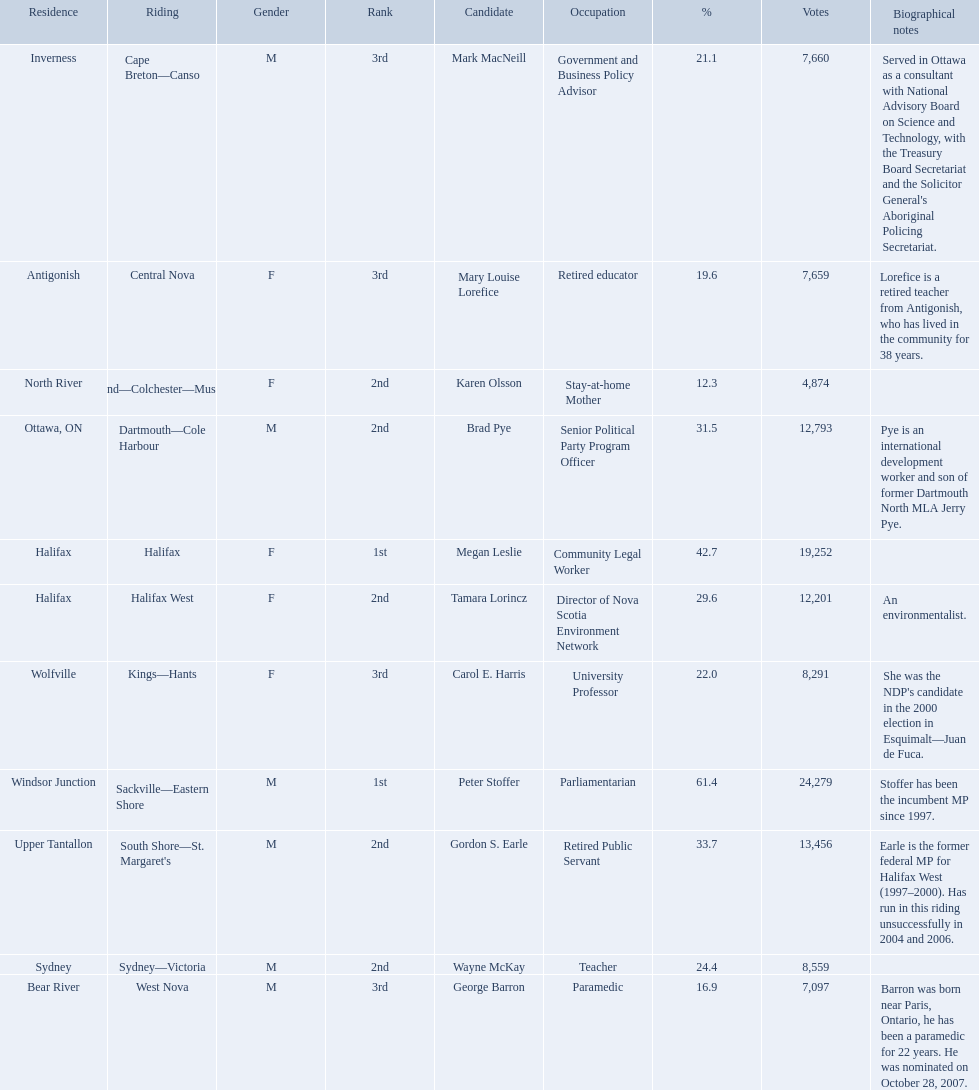Who were all of the new democratic party candidates during the 2008 canadian federal election? Mark MacNeill, Mary Louise Lorefice, Karen Olsson, Brad Pye, Megan Leslie, Tamara Lorincz, Carol E. Harris, Peter Stoffer, Gordon S. Earle, Wayne McKay, George Barron. And between mark macneill and karen olsson, which candidate received more votes? Mark MacNeill. 